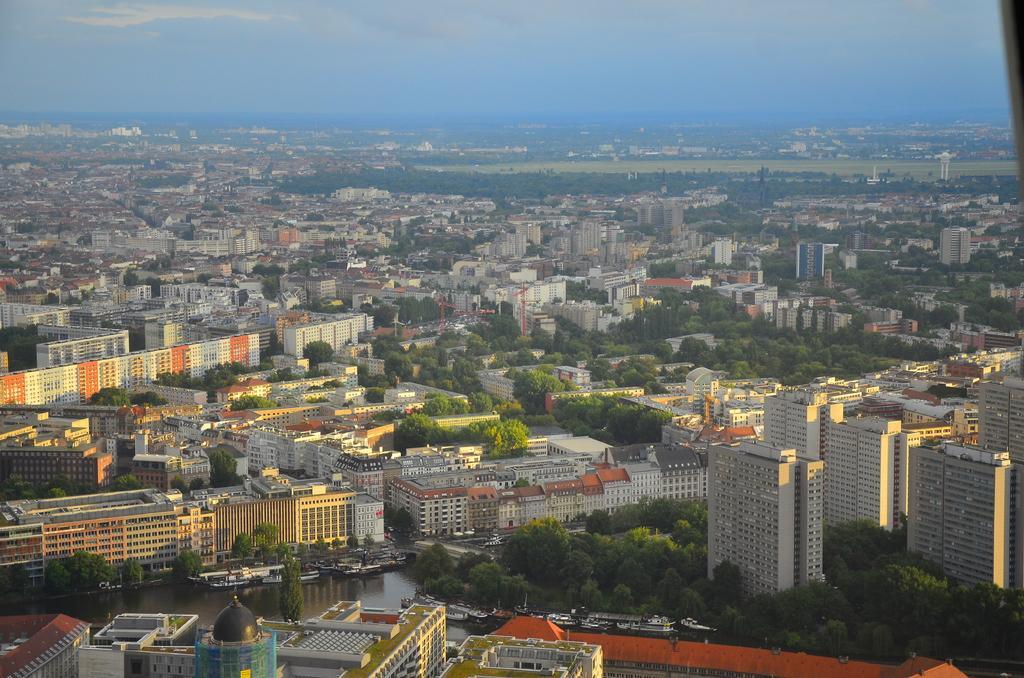Please provide a concise description of this image. In the image we can see there are many buildings and trees. Here we can see water and the sky. 